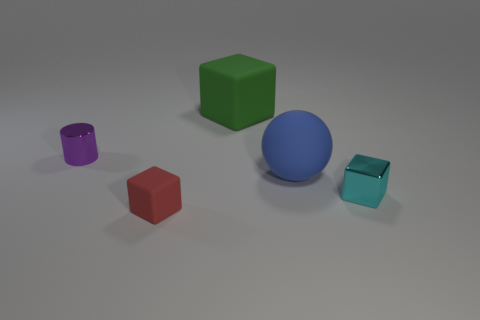How many other things are there of the same color as the cylinder?
Keep it short and to the point. 0. Is the material of the large object behind the large blue matte object the same as the small thing that is behind the tiny cyan block?
Your answer should be compact. No. Is the number of tiny red blocks behind the blue rubber sphere the same as the number of red rubber blocks that are behind the purple shiny cylinder?
Provide a short and direct response. Yes. What is the material of the tiny cylinder in front of the green cube?
Provide a succinct answer. Metal. Is the number of large blue spheres less than the number of small things?
Your answer should be compact. Yes. There is a small thing that is behind the tiny red rubber block and to the right of the purple metal object; what shape is it?
Provide a succinct answer. Cube. What number of small cyan things are there?
Ensure brevity in your answer.  1. There is a cyan block that is in front of the block behind the shiny object that is on the right side of the small red rubber thing; what is it made of?
Ensure brevity in your answer.  Metal. There is a tiny cyan metal thing right of the large rubber sphere; what number of cyan metallic cubes are to the right of it?
Provide a succinct answer. 0. What color is the other tiny metal thing that is the same shape as the small red object?
Your answer should be very brief. Cyan. 